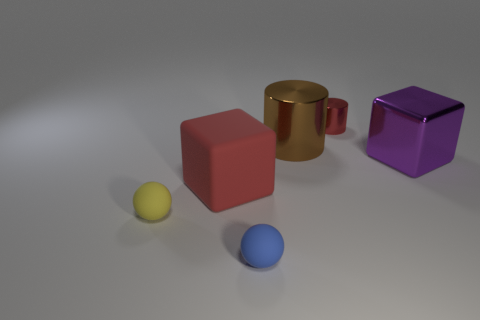Add 1 small green metallic spheres. How many objects exist? 7 Subtract all balls. How many objects are left? 4 Add 3 small cylinders. How many small cylinders are left? 4 Add 6 big purple objects. How many big purple objects exist? 7 Subtract 0 red spheres. How many objects are left? 6 Subtract all big brown shiny spheres. Subtract all blue balls. How many objects are left? 5 